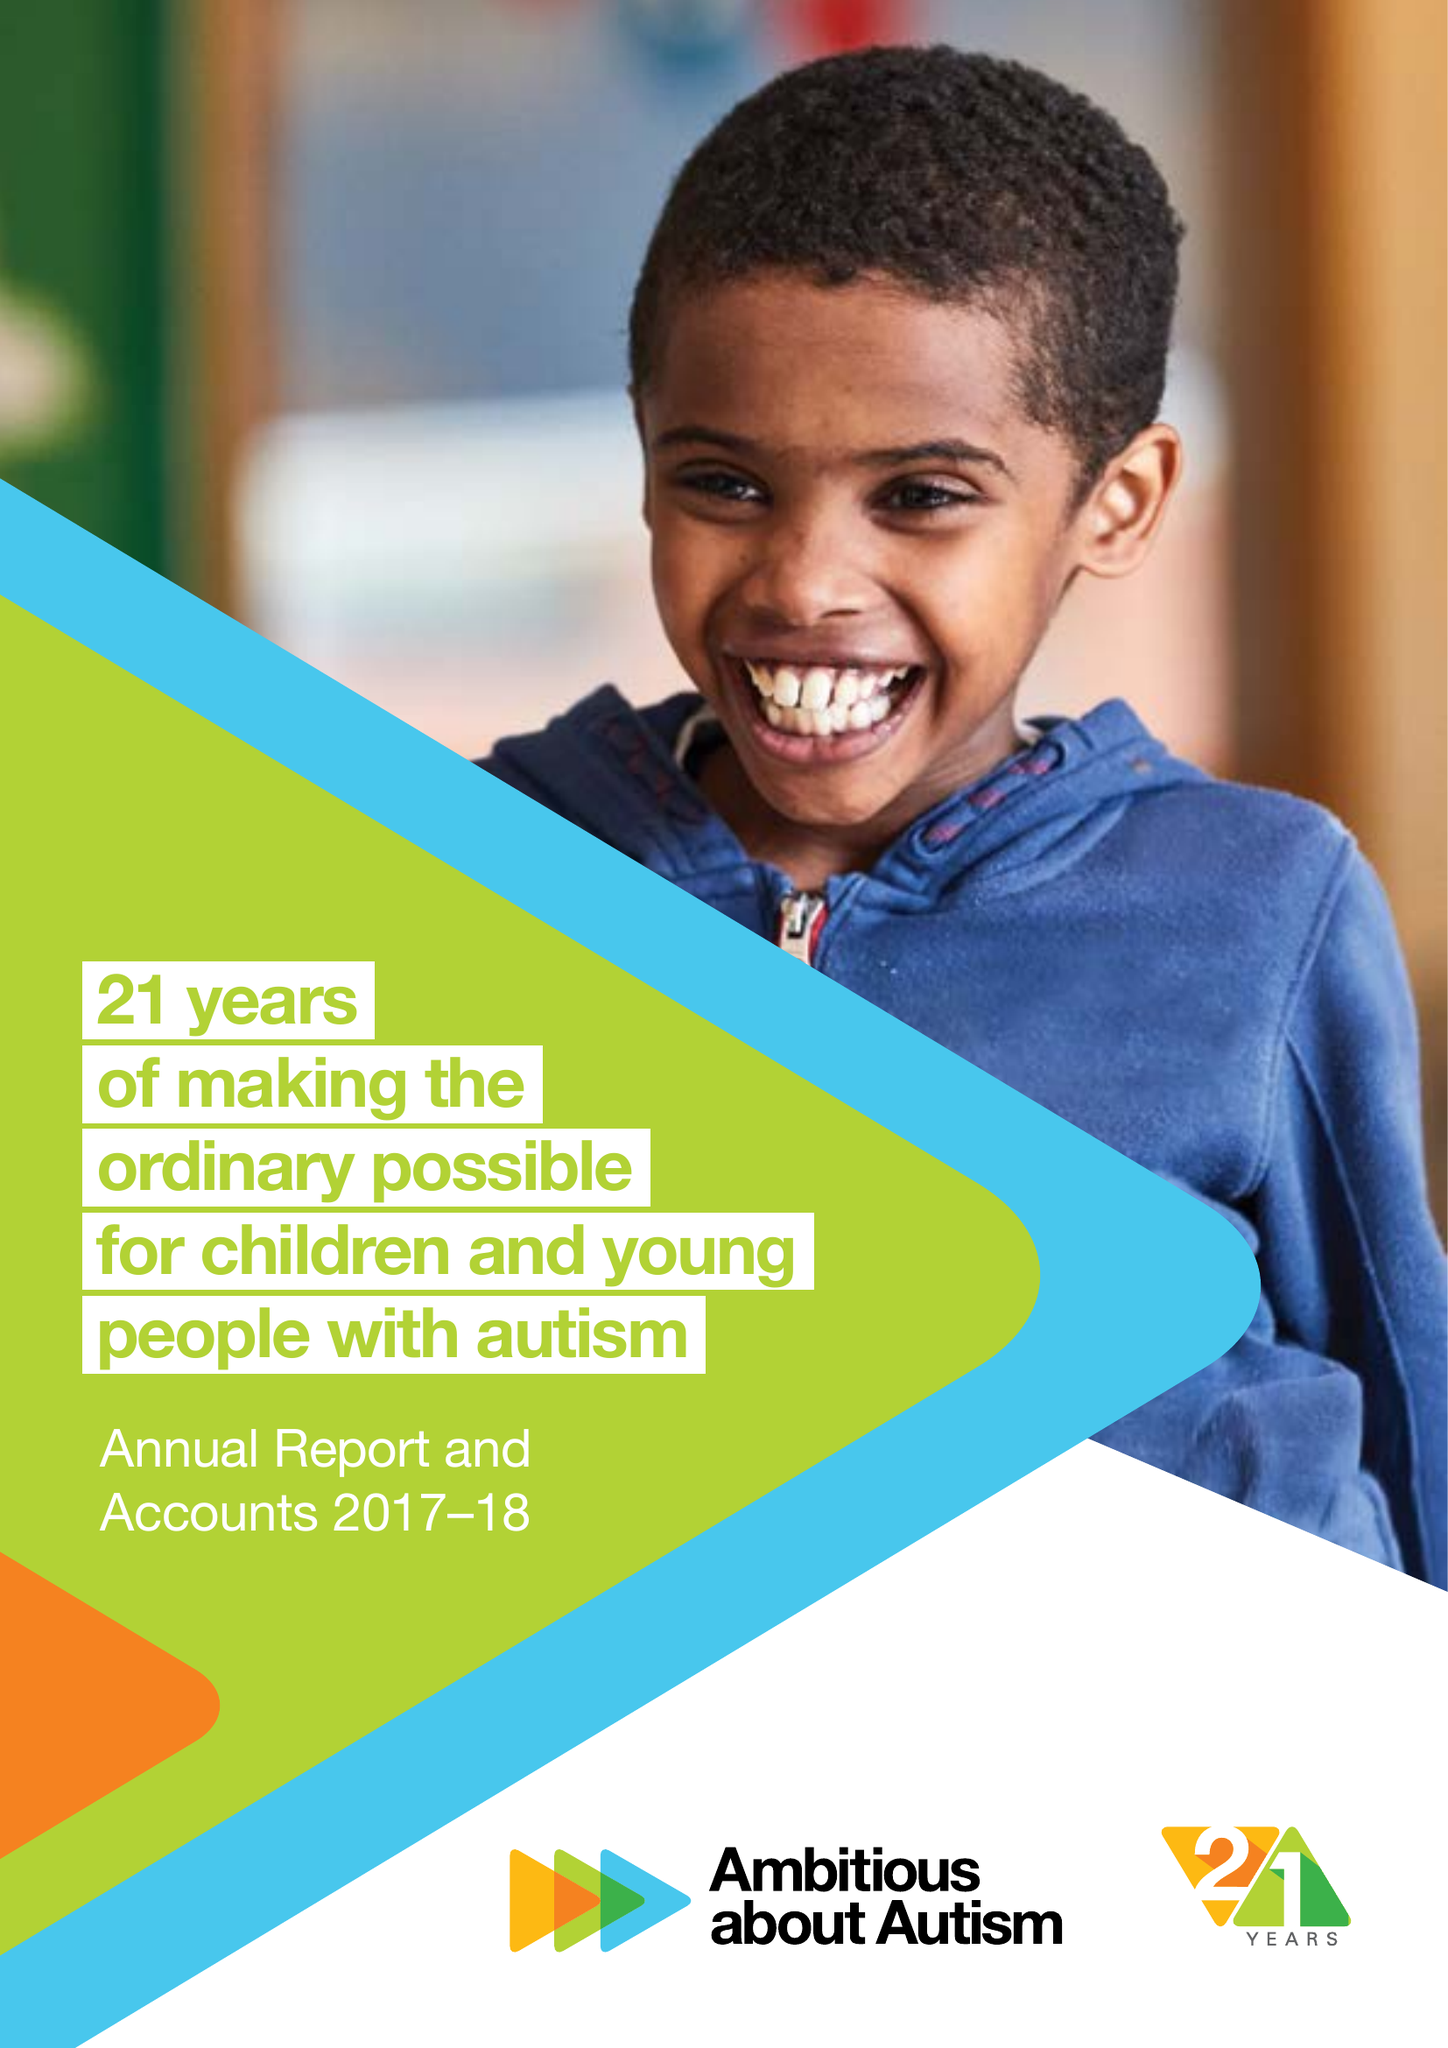What is the value for the income_annually_in_british_pounds?
Answer the question using a single word or phrase. 16462000.00 